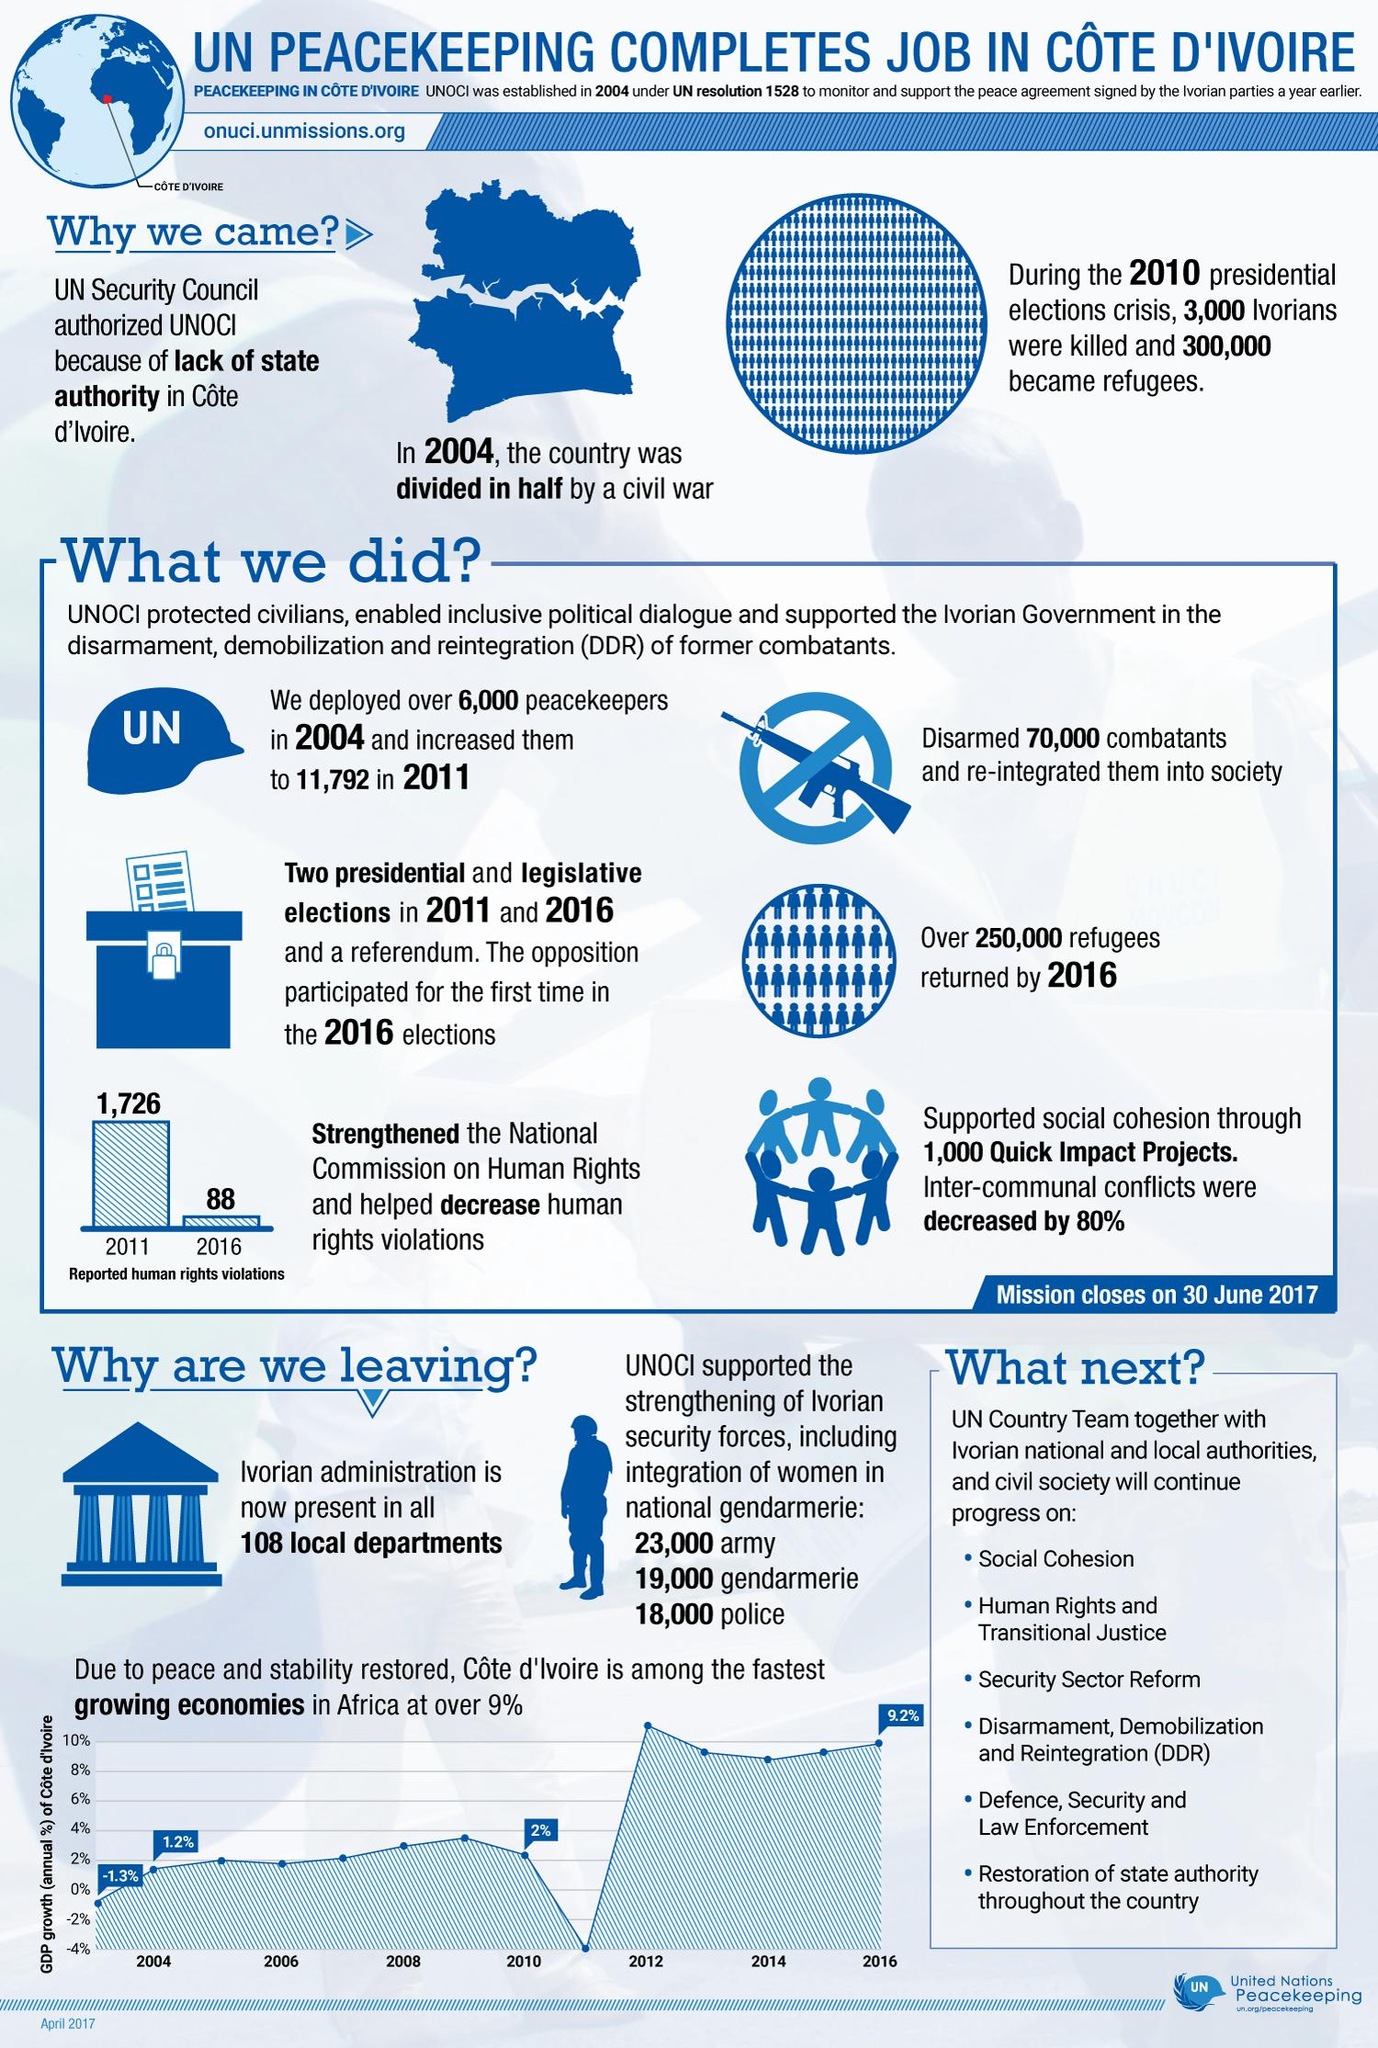Draw attention to some important aspects in this diagram. In 2010, the annual GDP growth of Cote d'Ivoire was 2%. The mission in Cote d'Ivoire was carried out due to the lack of state authority. There has been a significant decrease in reported human rights violations from 2011 to 2016, as reported by a number of sources. Specifically, the reported number of human rights violations decreased by 1,638. 